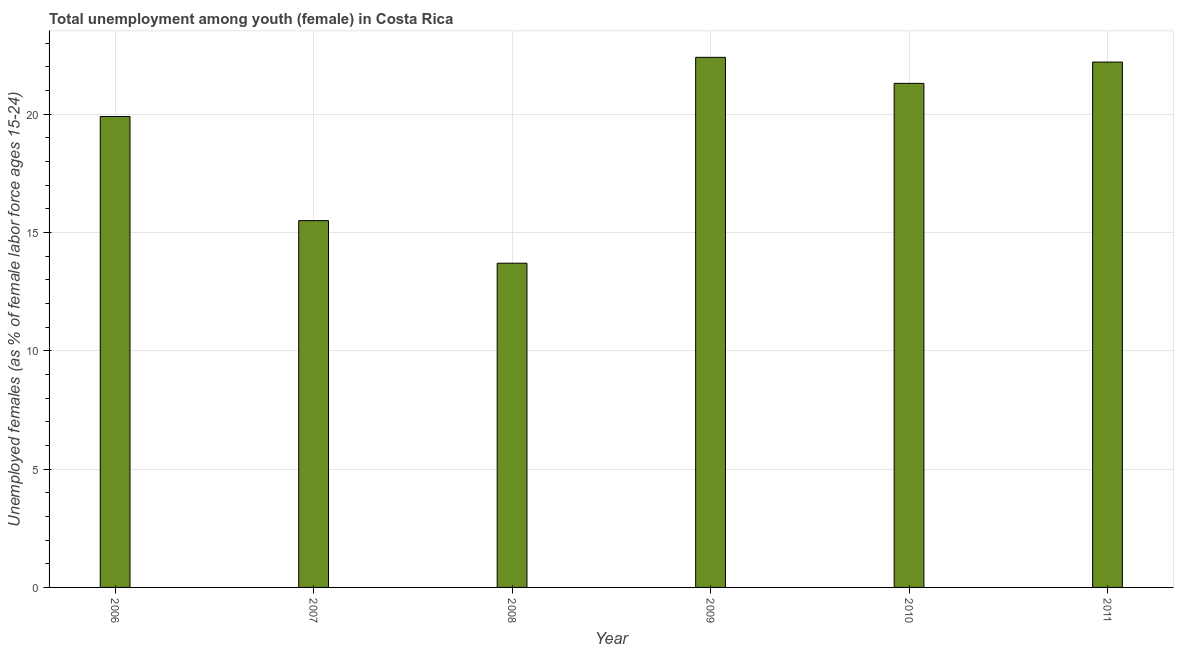Does the graph contain grids?
Your answer should be compact. Yes. What is the title of the graph?
Your response must be concise. Total unemployment among youth (female) in Costa Rica. What is the label or title of the Y-axis?
Your answer should be compact. Unemployed females (as % of female labor force ages 15-24). What is the unemployed female youth population in 2008?
Ensure brevity in your answer.  13.7. Across all years, what is the maximum unemployed female youth population?
Offer a terse response. 22.4. Across all years, what is the minimum unemployed female youth population?
Keep it short and to the point. 13.7. What is the sum of the unemployed female youth population?
Your answer should be compact. 115. What is the average unemployed female youth population per year?
Provide a succinct answer. 19.17. What is the median unemployed female youth population?
Offer a very short reply. 20.6. Is the difference between the unemployed female youth population in 2006 and 2011 greater than the difference between any two years?
Ensure brevity in your answer.  No. Is the sum of the unemployed female youth population in 2009 and 2010 greater than the maximum unemployed female youth population across all years?
Make the answer very short. Yes. In how many years, is the unemployed female youth population greater than the average unemployed female youth population taken over all years?
Your response must be concise. 4. Are all the bars in the graph horizontal?
Your answer should be compact. No. How many years are there in the graph?
Give a very brief answer. 6. What is the Unemployed females (as % of female labor force ages 15-24) of 2006?
Your response must be concise. 19.9. What is the Unemployed females (as % of female labor force ages 15-24) in 2007?
Your answer should be very brief. 15.5. What is the Unemployed females (as % of female labor force ages 15-24) in 2008?
Your response must be concise. 13.7. What is the Unemployed females (as % of female labor force ages 15-24) in 2009?
Give a very brief answer. 22.4. What is the Unemployed females (as % of female labor force ages 15-24) in 2010?
Your response must be concise. 21.3. What is the Unemployed females (as % of female labor force ages 15-24) of 2011?
Offer a very short reply. 22.2. What is the difference between the Unemployed females (as % of female labor force ages 15-24) in 2006 and 2010?
Offer a very short reply. -1.4. What is the difference between the Unemployed females (as % of female labor force ages 15-24) in 2007 and 2009?
Give a very brief answer. -6.9. What is the difference between the Unemployed females (as % of female labor force ages 15-24) in 2008 and 2010?
Offer a very short reply. -7.6. What is the difference between the Unemployed females (as % of female labor force ages 15-24) in 2009 and 2011?
Make the answer very short. 0.2. What is the difference between the Unemployed females (as % of female labor force ages 15-24) in 2010 and 2011?
Ensure brevity in your answer.  -0.9. What is the ratio of the Unemployed females (as % of female labor force ages 15-24) in 2006 to that in 2007?
Give a very brief answer. 1.28. What is the ratio of the Unemployed females (as % of female labor force ages 15-24) in 2006 to that in 2008?
Provide a succinct answer. 1.45. What is the ratio of the Unemployed females (as % of female labor force ages 15-24) in 2006 to that in 2009?
Make the answer very short. 0.89. What is the ratio of the Unemployed females (as % of female labor force ages 15-24) in 2006 to that in 2010?
Your answer should be very brief. 0.93. What is the ratio of the Unemployed females (as % of female labor force ages 15-24) in 2006 to that in 2011?
Keep it short and to the point. 0.9. What is the ratio of the Unemployed females (as % of female labor force ages 15-24) in 2007 to that in 2008?
Your response must be concise. 1.13. What is the ratio of the Unemployed females (as % of female labor force ages 15-24) in 2007 to that in 2009?
Your answer should be very brief. 0.69. What is the ratio of the Unemployed females (as % of female labor force ages 15-24) in 2007 to that in 2010?
Your response must be concise. 0.73. What is the ratio of the Unemployed females (as % of female labor force ages 15-24) in 2007 to that in 2011?
Make the answer very short. 0.7. What is the ratio of the Unemployed females (as % of female labor force ages 15-24) in 2008 to that in 2009?
Give a very brief answer. 0.61. What is the ratio of the Unemployed females (as % of female labor force ages 15-24) in 2008 to that in 2010?
Give a very brief answer. 0.64. What is the ratio of the Unemployed females (as % of female labor force ages 15-24) in 2008 to that in 2011?
Offer a terse response. 0.62. What is the ratio of the Unemployed females (as % of female labor force ages 15-24) in 2009 to that in 2010?
Give a very brief answer. 1.05. What is the ratio of the Unemployed females (as % of female labor force ages 15-24) in 2010 to that in 2011?
Your answer should be compact. 0.96. 